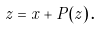<formula> <loc_0><loc_0><loc_500><loc_500>z = x + P ( z ) \, .</formula> 